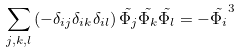<formula> <loc_0><loc_0><loc_500><loc_500>\sum _ { j , k , l } \left ( - \delta _ { i j } \delta _ { i k } \delta _ { i l } \right ) \tilde { \Phi _ { j } } \tilde { \Phi _ { k } } \tilde { \Phi _ { l } } = - \tilde { \Phi _ { i } } ^ { 3 }</formula> 